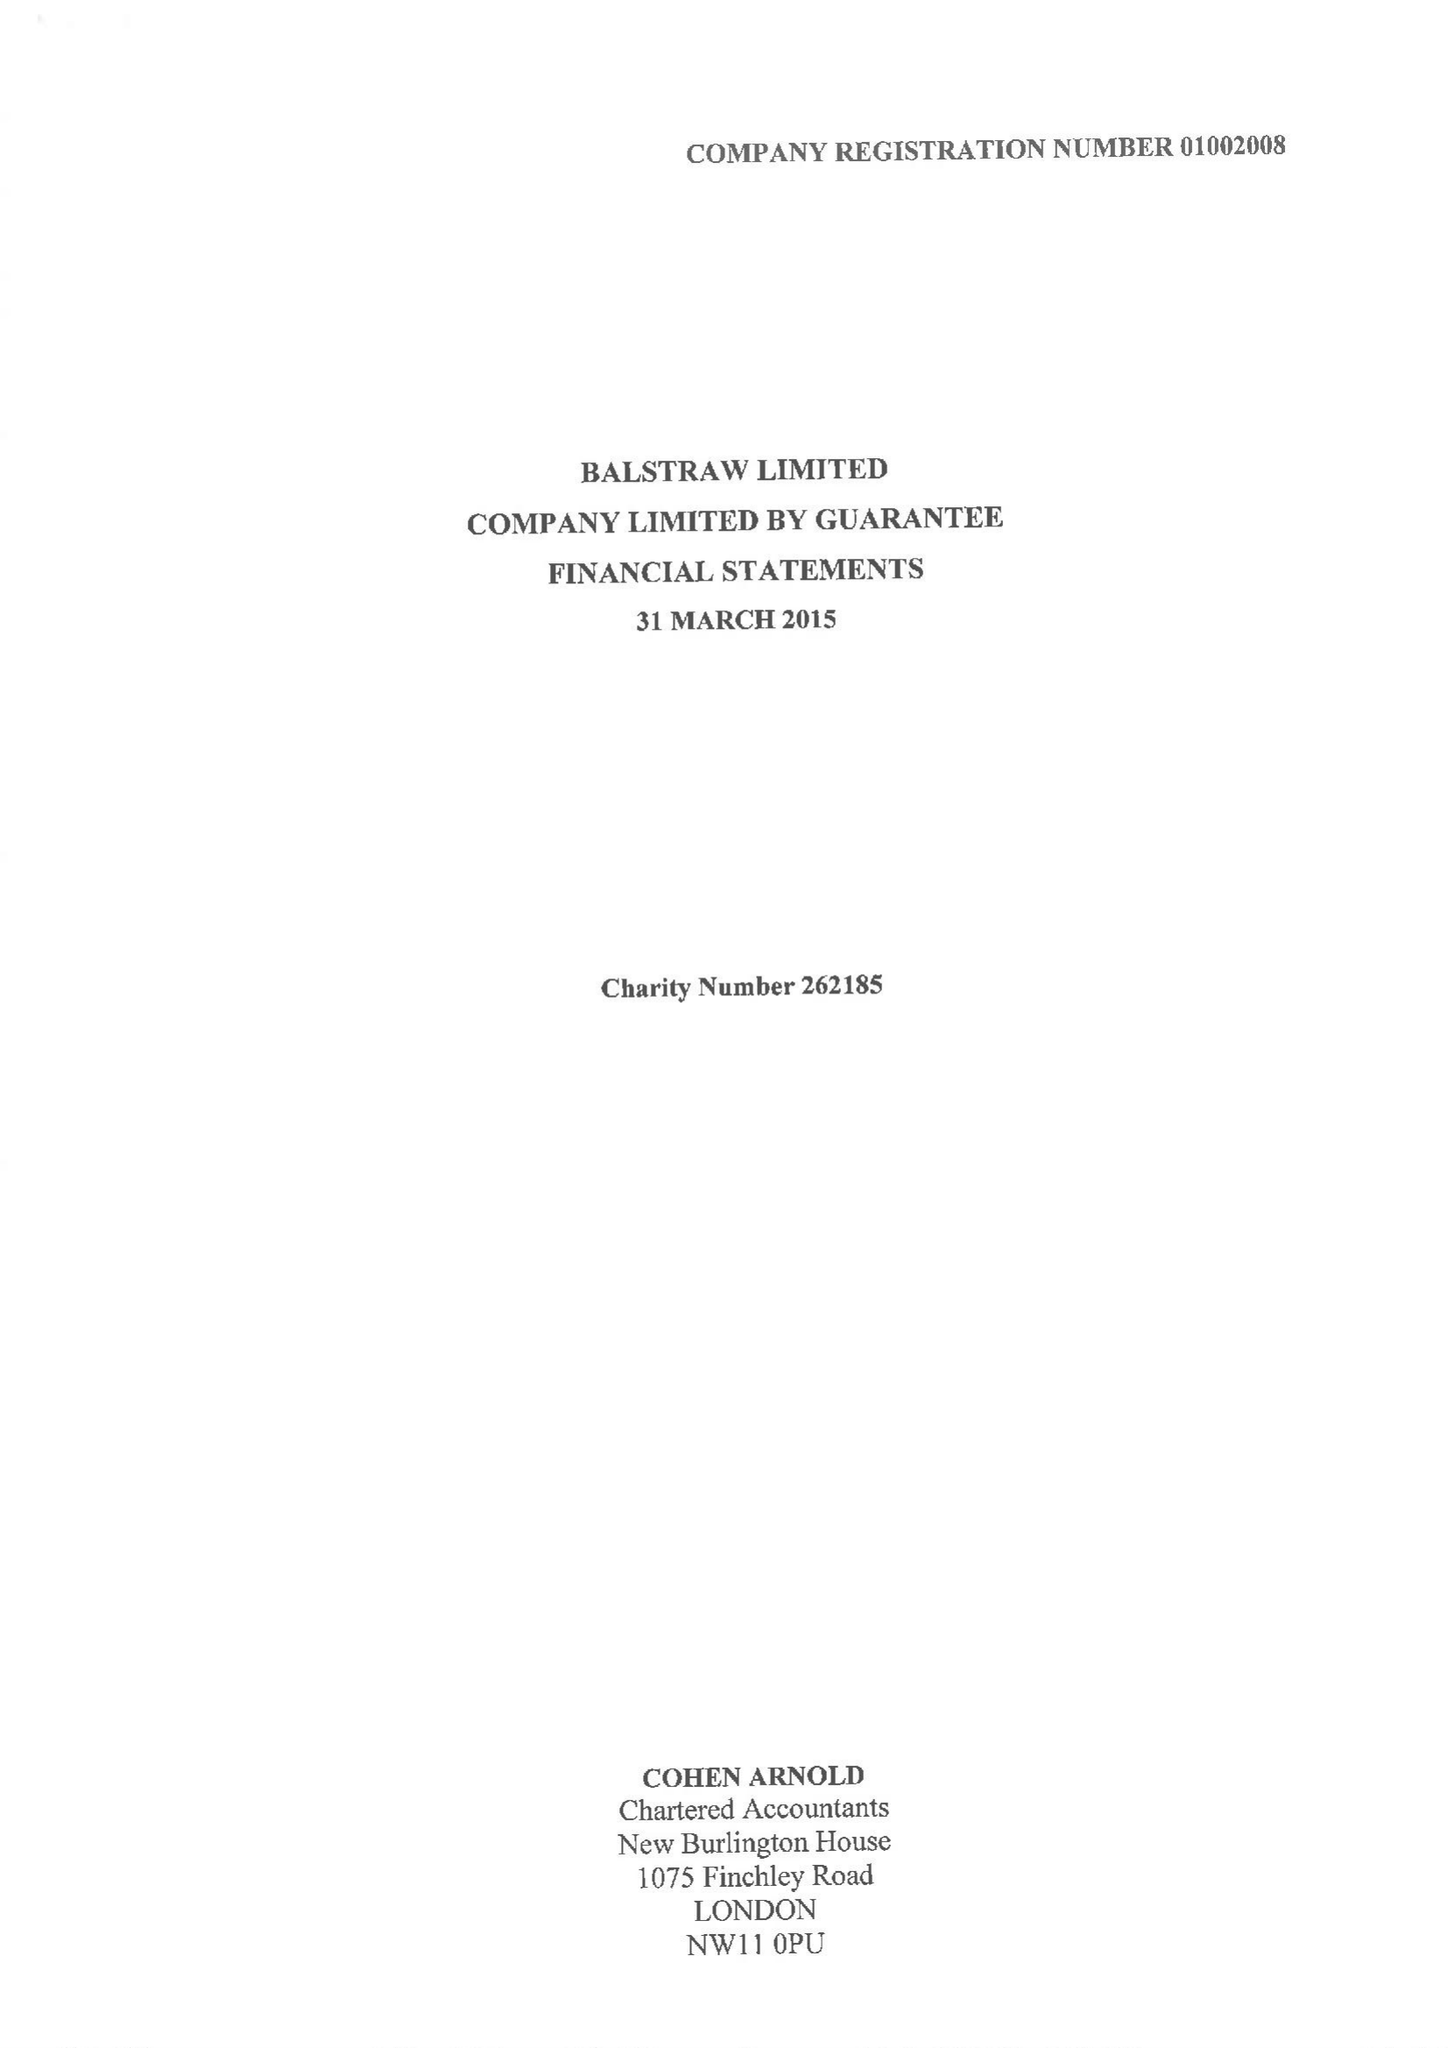What is the value for the income_annually_in_british_pounds?
Answer the question using a single word or phrase. 934407.00 